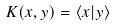Convert formula to latex. <formula><loc_0><loc_0><loc_500><loc_500>K ( x , y ) = \langle x | y \rangle</formula> 